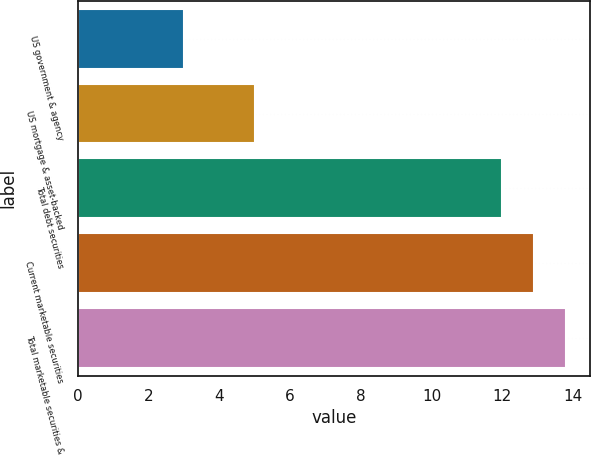Convert chart to OTSL. <chart><loc_0><loc_0><loc_500><loc_500><bar_chart><fcel>US government & agency<fcel>US mortgage & asset-backed<fcel>Total debt securities<fcel>Current marketable securities<fcel>Total marketable securities &<nl><fcel>3<fcel>5<fcel>12<fcel>12.9<fcel>13.8<nl></chart> 